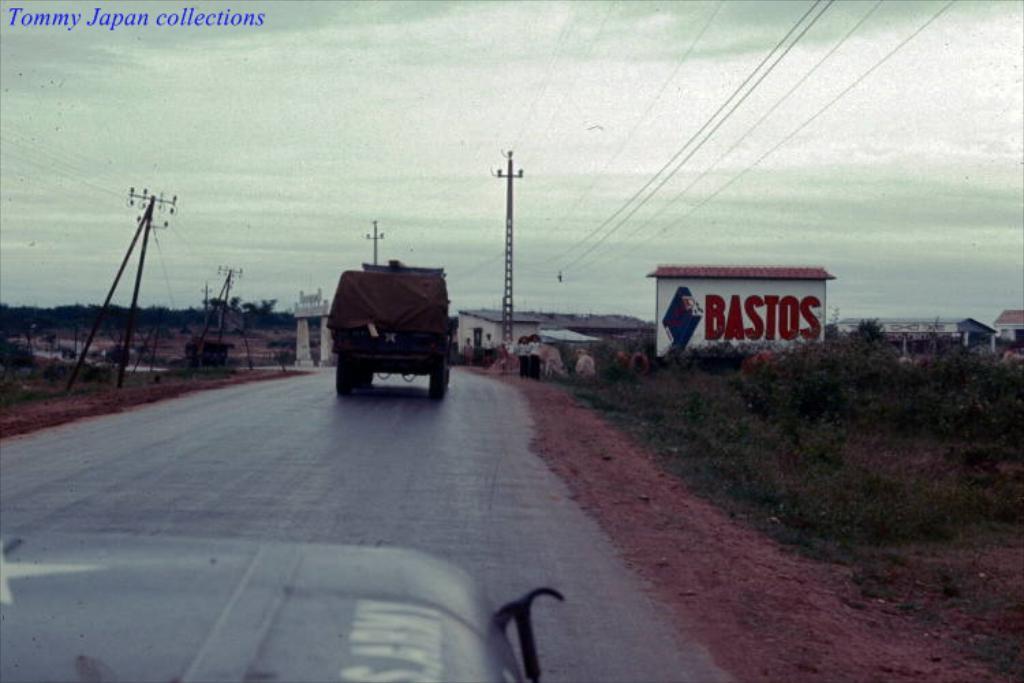Can you describe this image briefly? In this picture we can see a part of a vehicle and a vehicle on the road. There are wires on the poles. We can see grass, plants, houses, trees, other objects and the sky. We can see the text in the top left. 